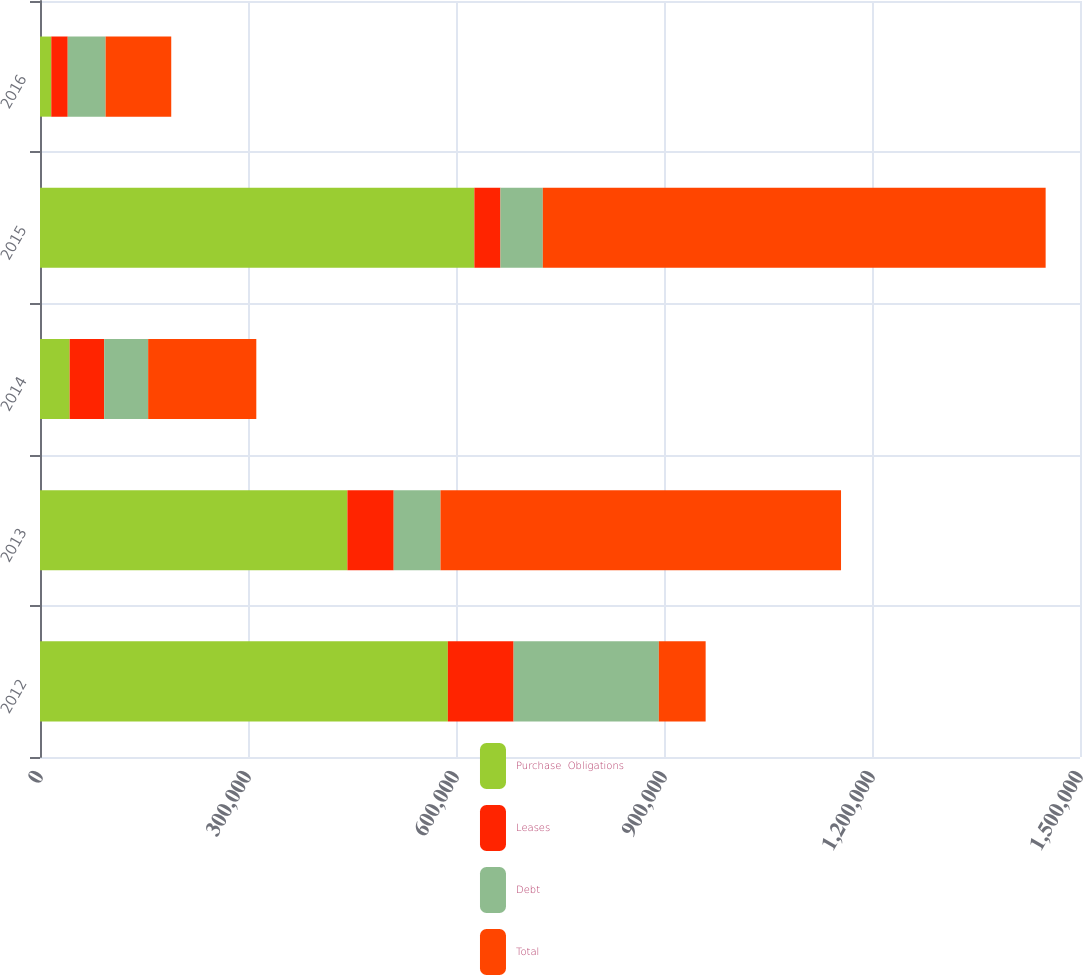<chart> <loc_0><loc_0><loc_500><loc_500><stacked_bar_chart><ecel><fcel>2012<fcel>2013<fcel>2014<fcel>2015<fcel>2016<nl><fcel>Purchase  Obligations<fcel>588222<fcel>443370<fcel>42786<fcel>626484<fcel>16261<nl><fcel>Leases<fcel>94853<fcel>66771<fcel>49820<fcel>37587<fcel>23730<nl><fcel>Debt<fcel>209469<fcel>67523<fcel>63384<fcel>61152<fcel>54652<nl><fcel>Total<fcel>67523<fcel>577664<fcel>155990<fcel>725223<fcel>94643<nl></chart> 